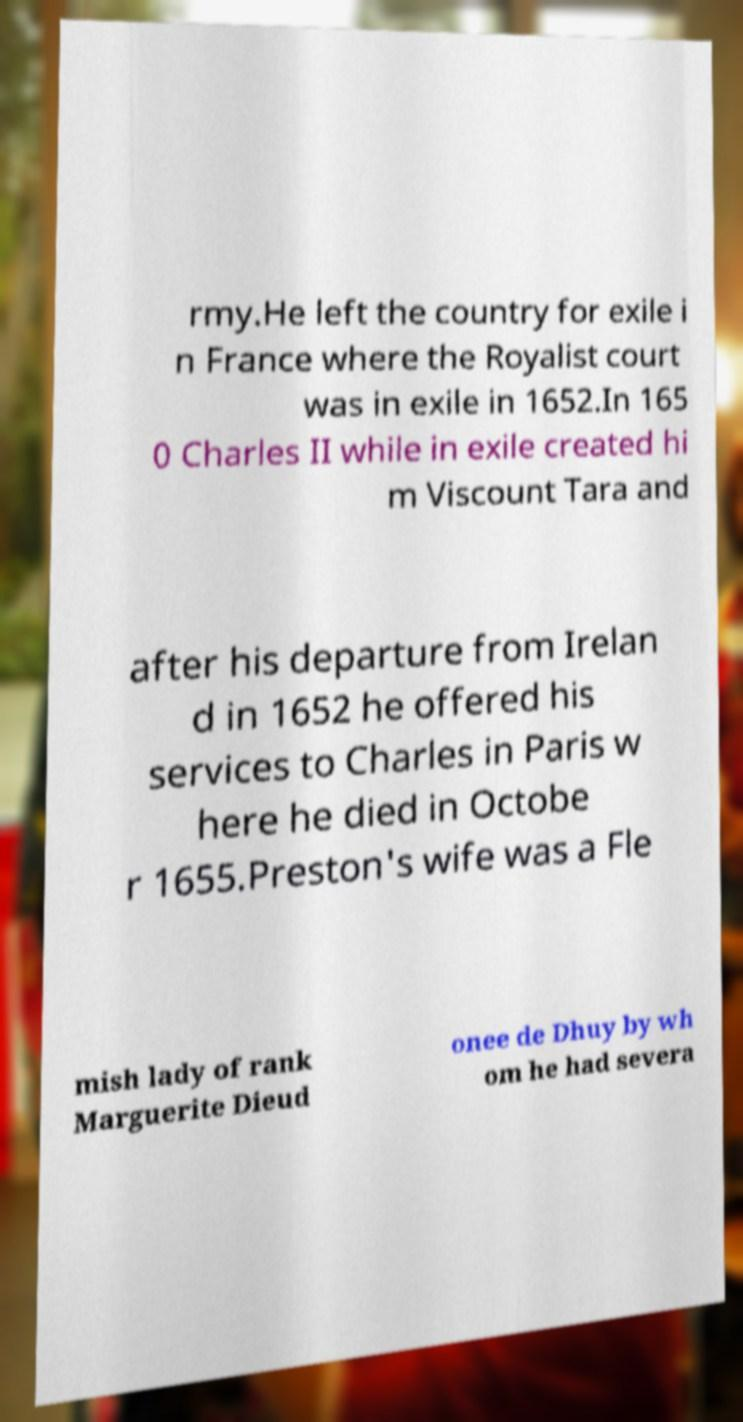Can you accurately transcribe the text from the provided image for me? rmy.He left the country for exile i n France where the Royalist court was in exile in 1652.In 165 0 Charles II while in exile created hi m Viscount Tara and after his departure from Irelan d in 1652 he offered his services to Charles in Paris w here he died in Octobe r 1655.Preston's wife was a Fle mish lady of rank Marguerite Dieud onee de Dhuy by wh om he had severa 